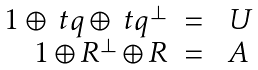Convert formula to latex. <formula><loc_0><loc_0><loc_500><loc_500>\begin{array} { r c l } 1 \oplus \ t q \oplus \ t q ^ { \perp } & = & \ U \\ 1 \oplus R ^ { \perp } \oplus R & = & \ A \end{array}</formula> 